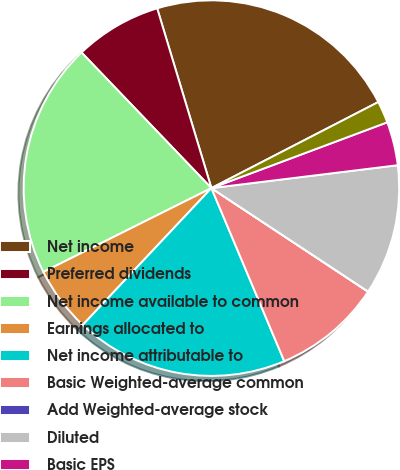Convert chart to OTSL. <chart><loc_0><loc_0><loc_500><loc_500><pie_chart><fcel>Net income<fcel>Preferred dividends<fcel>Net income available to common<fcel>Earnings allocated to<fcel>Net income attributable to<fcel>Basic Weighted-average common<fcel>Add Weighted-average stock<fcel>Diluted<fcel>Basic EPS<fcel>Diluted EPS<nl><fcel>22.08%<fcel>7.49%<fcel>20.21%<fcel>5.62%<fcel>18.35%<fcel>9.36%<fcel>0.01%<fcel>11.23%<fcel>3.75%<fcel>1.88%<nl></chart> 